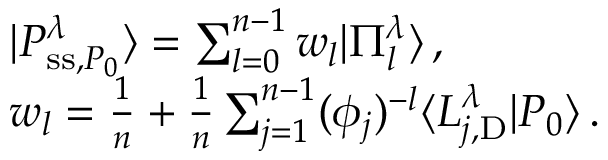<formula> <loc_0><loc_0><loc_500><loc_500>\begin{array} { r l } & { | P _ { s s , P _ { 0 } } ^ { \lambda } \rangle = \sum _ { l = 0 } ^ { n - 1 } w _ { l } | \Pi _ { l } ^ { \lambda } \rangle \, , } \\ & { w _ { l } = \frac { 1 } { n } + \frac { 1 } { n } \sum _ { j = 1 } ^ { n - 1 } ( \phi _ { j } ) ^ { - l } \langle L _ { j , D } ^ { \lambda } | P _ { 0 } \rangle \, . } \end{array}</formula> 